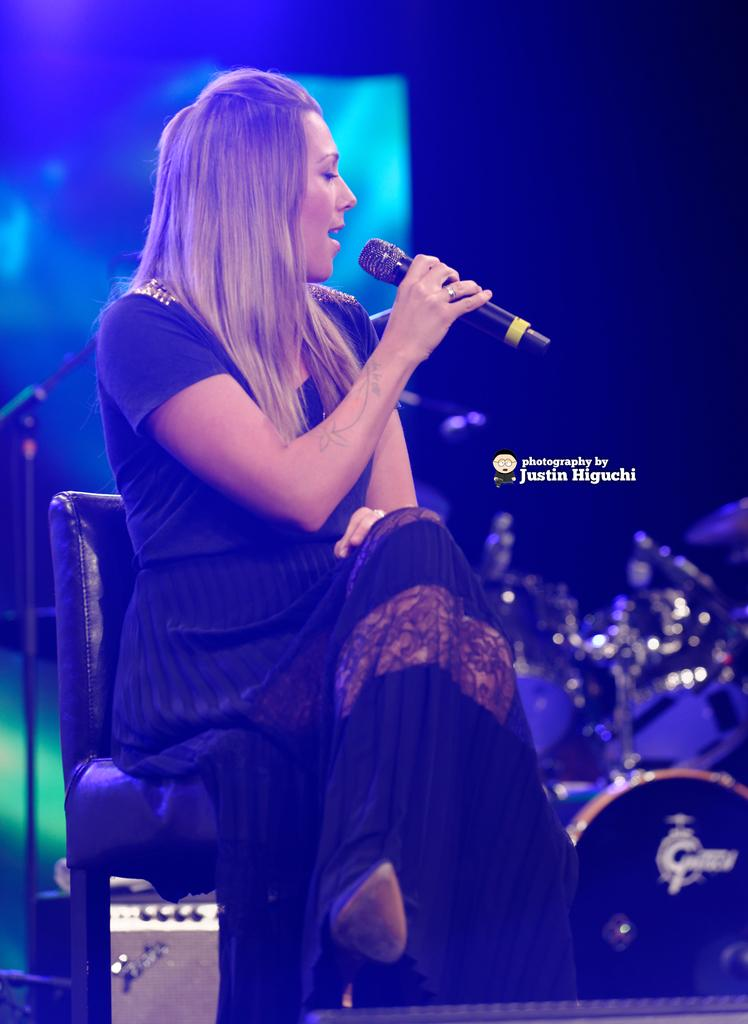Who is the main subject in the image? There is a woman in the image. What is the woman doing in the image? The woman is sitting on a chair and singing. What is the woman holding in the image? The woman is holding a microphone. What can be seen in the background of the image? The background of the image is dark, and there is a stand and a device on a surface. Reasoning: Let's think step by step by step in order to produce the conversation. We start by identifying the main subject in the image, which is the woman. Then, we describe her actions and the object she is holding, which is a microphone. Next, we mention the background of the image, which is dark, and include the additional details of the stand and the device on a surface. Each question is designed to elicit a specific detail about the image that is known from the provided facts. Absurd Question/Answer: What flavor of shoes is the woman wearing in the image? There is no mention of shoes in the image, so it is not possible to determine the flavor of any shoes the woman might be wearing. 